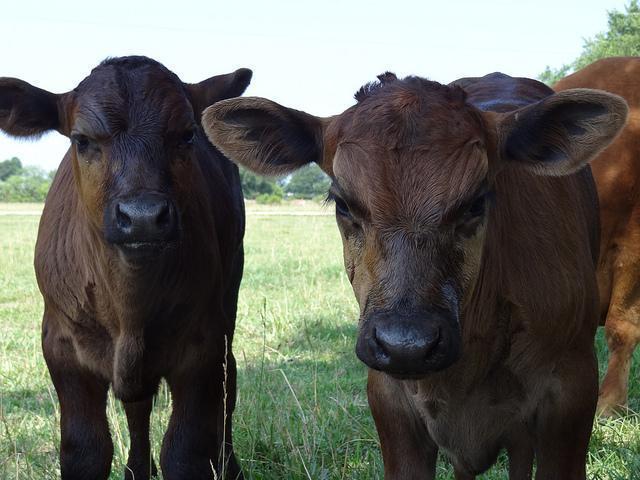How many cows can be seen?
Give a very brief answer. 3. 